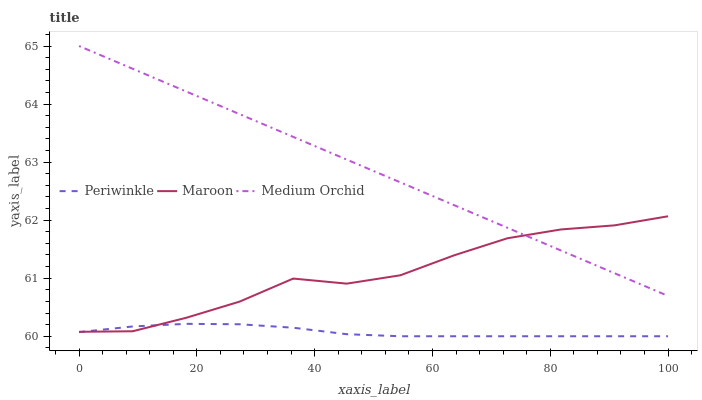Does Periwinkle have the minimum area under the curve?
Answer yes or no. Yes. Does Medium Orchid have the maximum area under the curve?
Answer yes or no. Yes. Does Maroon have the minimum area under the curve?
Answer yes or no. No. Does Maroon have the maximum area under the curve?
Answer yes or no. No. Is Medium Orchid the smoothest?
Answer yes or no. Yes. Is Maroon the roughest?
Answer yes or no. Yes. Is Periwinkle the smoothest?
Answer yes or no. No. Is Periwinkle the roughest?
Answer yes or no. No. Does Periwinkle have the lowest value?
Answer yes or no. Yes. Does Maroon have the lowest value?
Answer yes or no. No. Does Medium Orchid have the highest value?
Answer yes or no. Yes. Does Maroon have the highest value?
Answer yes or no. No. Is Periwinkle less than Medium Orchid?
Answer yes or no. Yes. Is Medium Orchid greater than Periwinkle?
Answer yes or no. Yes. Does Periwinkle intersect Maroon?
Answer yes or no. Yes. Is Periwinkle less than Maroon?
Answer yes or no. No. Is Periwinkle greater than Maroon?
Answer yes or no. No. Does Periwinkle intersect Medium Orchid?
Answer yes or no. No. 